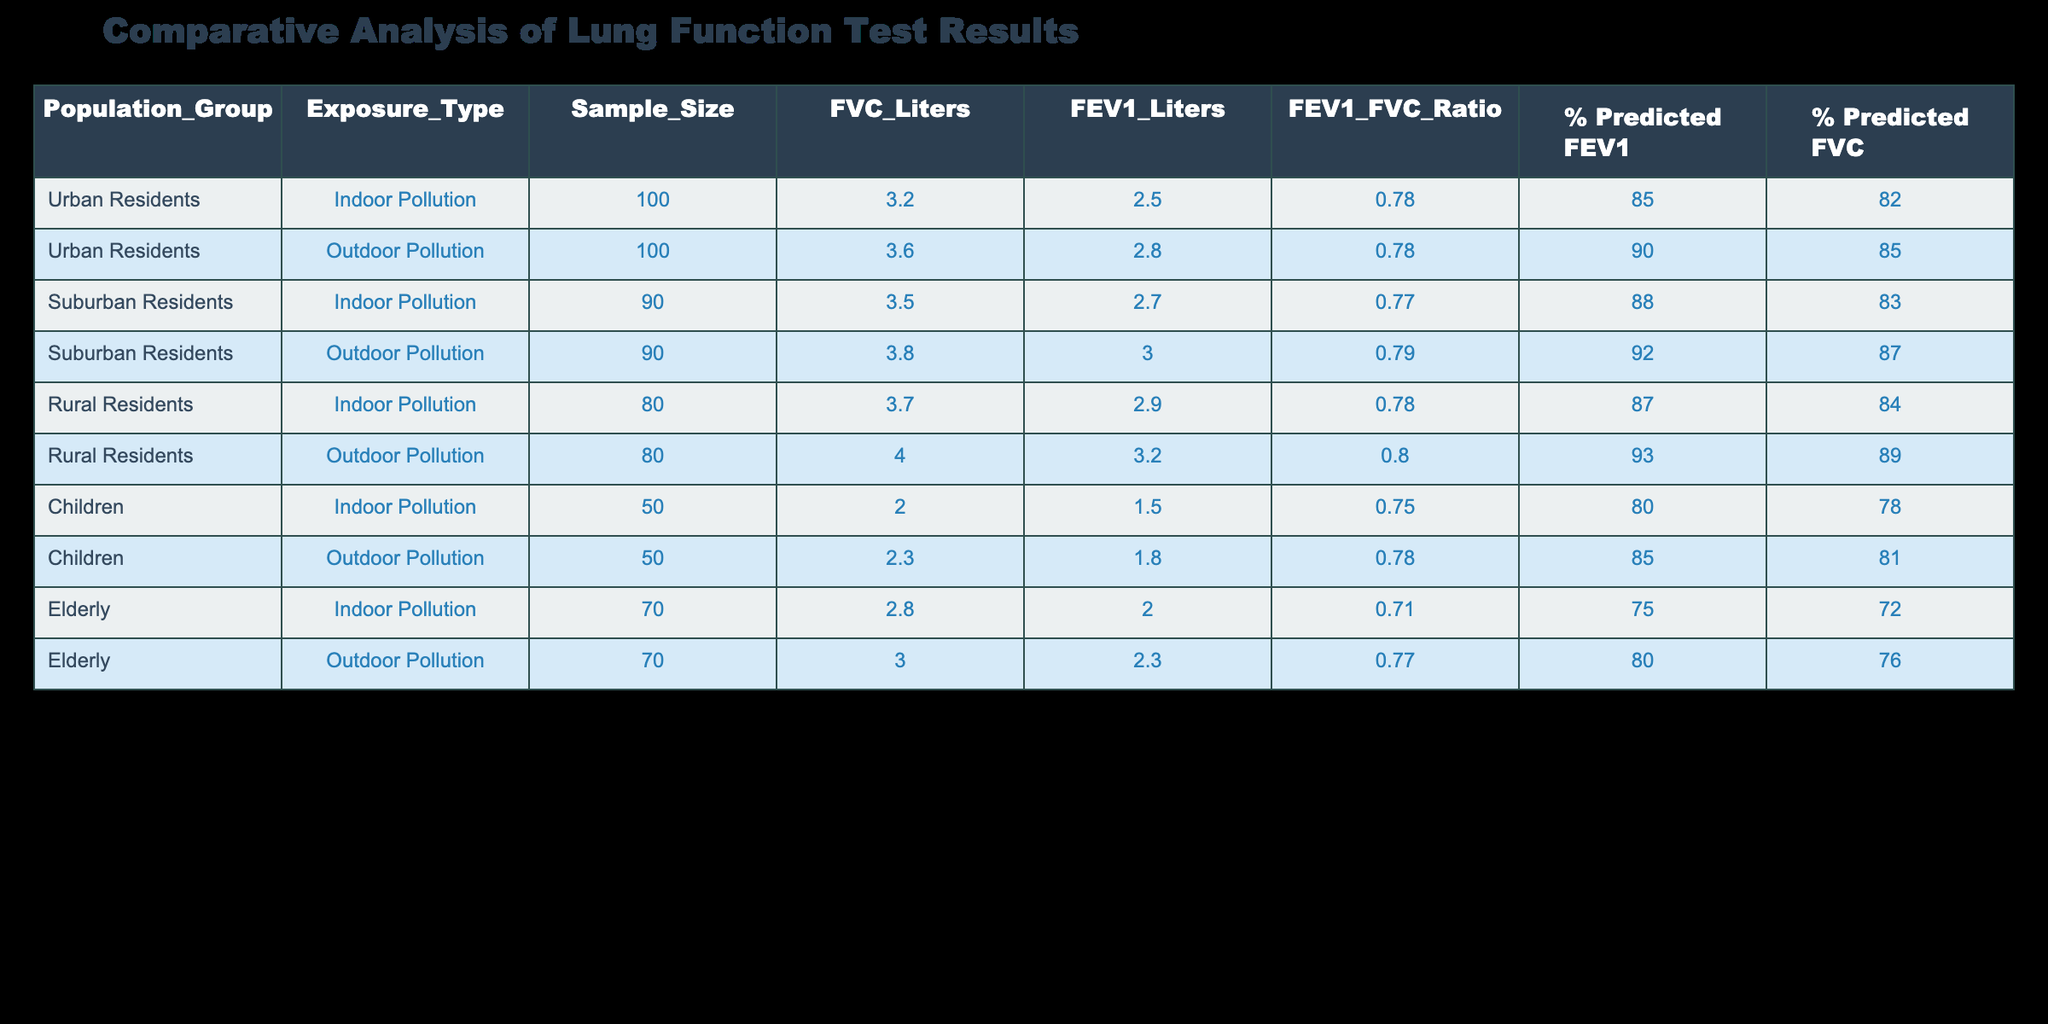What is the sample size for urban residents exposed to outdoor pollution? The table indicates that the sample size for urban residents exposed to outdoor pollution is 100.
Answer: 100 What is the FEV1 value for suburban residents exposed to indoor pollution? According to the table, the FEV1 value for suburban residents exposed to indoor pollution is 2.7 liters.
Answer: 2.7 liters Is the FEV1/FVC ratio higher for children exposed to outdoor pollution compared to those exposed to indoor pollution? For children exposed to outdoor pollution, the FEV1/FVC ratio is 0.78, while for those exposed to indoor pollution, it is 0.75. Since 0.78 is greater than 0.75, the statement is true.
Answer: Yes What is the average FVC value for rural residents exposed to both pollution types? The FVC values for rural residents are 3.7 liters (indoor) and 4.0 liters (outdoor). The average is (3.7 + 4.0) / 2 = 3.85 liters.
Answer: 3.85 liters Which population group has the highest % predicted FEV1 when exposed to outdoor pollution? The table shows that rural residents have the highest % predicted FEV1 at 93% when exposed to outdoor pollution.
Answer: Rural residents What is the difference in % predicted FVC between urban residents exposed to indoor pollution and suburban residents exposed to outdoor pollution? % predicted FVC for urban residents exposed to indoor pollution is 82% and for suburban residents it is 87%. The difference is 87% - 82% = 5%.
Answer: 5% Is it true that the elderly have a higher FVC value when exposed to outdoor pollution compared to suburban residents exposed to indoor pollution? The elderly have an FVC value of 3.0 liters when exposed to outdoor pollution, while suburban residents exposed to indoor pollution have an FVC value of 3.5 liters. Since 3.0 liters is less than 3.5 liters, the statement is false.
Answer: No What is the FEV1/FVC ratio for rural residents exposed to indoor pollution? The table indicates that the FEV1/FVC ratio for rural residents exposed to indoor pollution is 0.78.
Answer: 0.78 Which population group shows the lowest % predicted FEV1 among all the groups exposed to indoor pollution? Among the groups exposed to indoor pollution, the elderly have the lowest % predicted FEV1 of 75%.
Answer: Elderly 